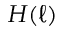Convert formula to latex. <formula><loc_0><loc_0><loc_500><loc_500>H ( \ell )</formula> 